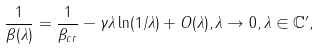Convert formula to latex. <formula><loc_0><loc_0><loc_500><loc_500>\frac { 1 } { \beta ( \lambda ) } = \frac { 1 } { \beta _ { c r } } - \gamma \lambda \ln ( 1 / \lambda ) + O ( \lambda ) , \lambda \rightarrow 0 , \lambda \in \mathbb { C } ^ { \prime } ,</formula> 